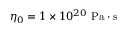<formula> <loc_0><loc_0><loc_500><loc_500>\eta _ { 0 } = 1 \times 1 0 ^ { 2 0 } \ P a \cdot s</formula> 